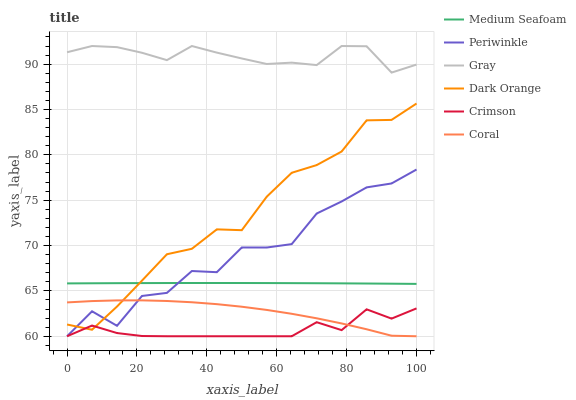Does Crimson have the minimum area under the curve?
Answer yes or no. Yes. Does Gray have the maximum area under the curve?
Answer yes or no. Yes. Does Dark Orange have the minimum area under the curve?
Answer yes or no. No. Does Dark Orange have the maximum area under the curve?
Answer yes or no. No. Is Medium Seafoam the smoothest?
Answer yes or no. Yes. Is Periwinkle the roughest?
Answer yes or no. Yes. Is Dark Orange the smoothest?
Answer yes or no. No. Is Dark Orange the roughest?
Answer yes or no. No. Does Coral have the lowest value?
Answer yes or no. Yes. Does Dark Orange have the lowest value?
Answer yes or no. No. Does Gray have the highest value?
Answer yes or no. Yes. Does Dark Orange have the highest value?
Answer yes or no. No. Is Medium Seafoam less than Gray?
Answer yes or no. Yes. Is Gray greater than Coral?
Answer yes or no. Yes. Does Periwinkle intersect Crimson?
Answer yes or no. Yes. Is Periwinkle less than Crimson?
Answer yes or no. No. Is Periwinkle greater than Crimson?
Answer yes or no. No. Does Medium Seafoam intersect Gray?
Answer yes or no. No. 